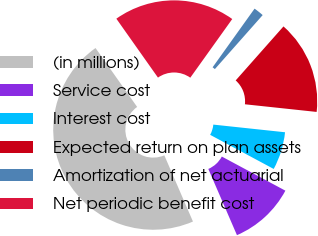Convert chart. <chart><loc_0><loc_0><loc_500><loc_500><pie_chart><fcel>(in millions)<fcel>Service cost<fcel>Interest cost<fcel>Expected return on plan assets<fcel>Amortization of net actuarial<fcel>Net periodic benefit cost<nl><fcel>46.71%<fcel>10.66%<fcel>6.15%<fcel>15.16%<fcel>1.65%<fcel>19.67%<nl></chart> 